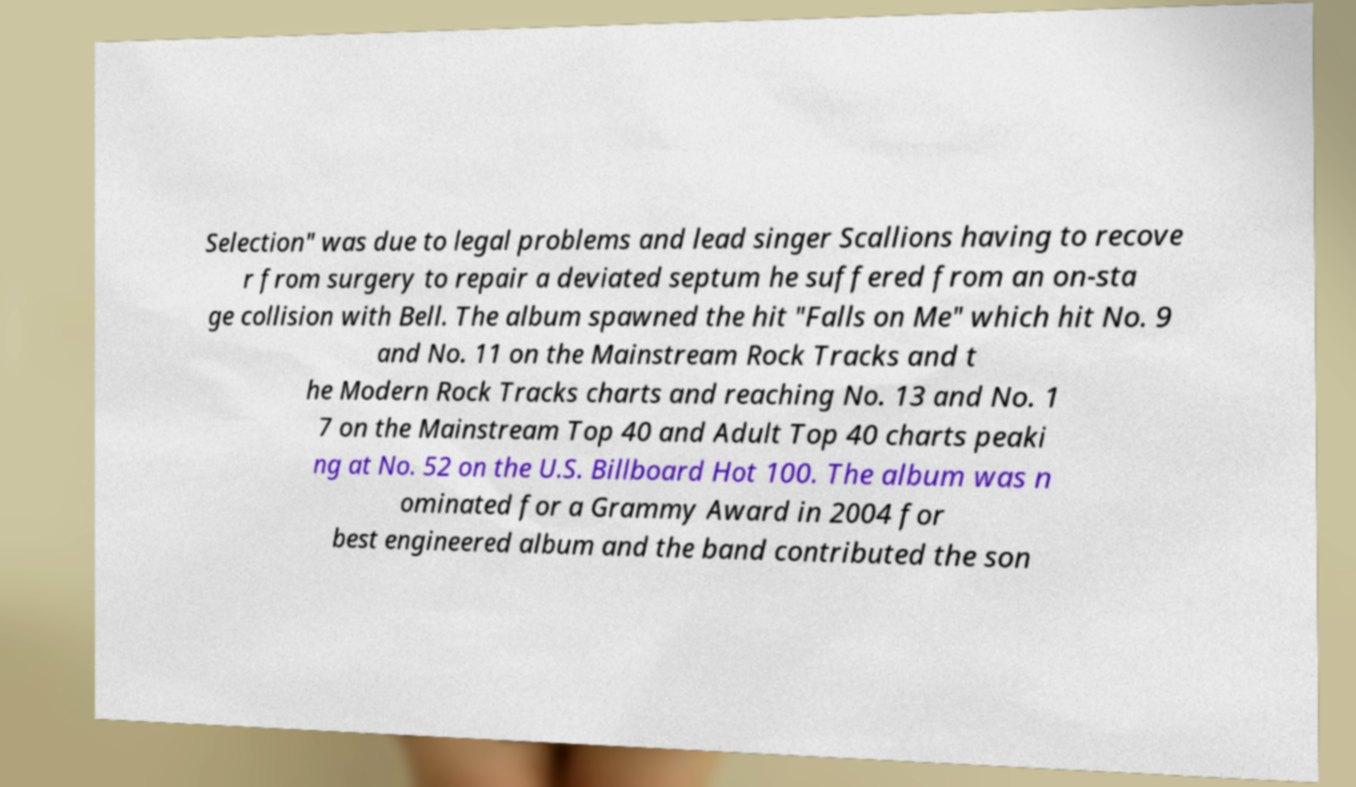What messages or text are displayed in this image? I need them in a readable, typed format. Selection" was due to legal problems and lead singer Scallions having to recove r from surgery to repair a deviated septum he suffered from an on-sta ge collision with Bell. The album spawned the hit "Falls on Me" which hit No. 9 and No. 11 on the Mainstream Rock Tracks and t he Modern Rock Tracks charts and reaching No. 13 and No. 1 7 on the Mainstream Top 40 and Adult Top 40 charts peaki ng at No. 52 on the U.S. Billboard Hot 100. The album was n ominated for a Grammy Award in 2004 for best engineered album and the band contributed the son 